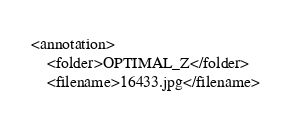Convert code to text. <code><loc_0><loc_0><loc_500><loc_500><_XML_><annotation>
	<folder>OPTIMAL_Z</folder>
	<filename>16433.jpg</filename></code> 